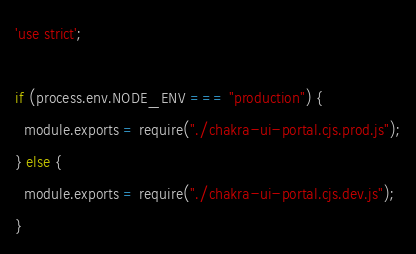Convert code to text. <code><loc_0><loc_0><loc_500><loc_500><_JavaScript_>'use strict';

if (process.env.NODE_ENV === "production") {
  module.exports = require("./chakra-ui-portal.cjs.prod.js");
} else {
  module.exports = require("./chakra-ui-portal.cjs.dev.js");
}
</code> 